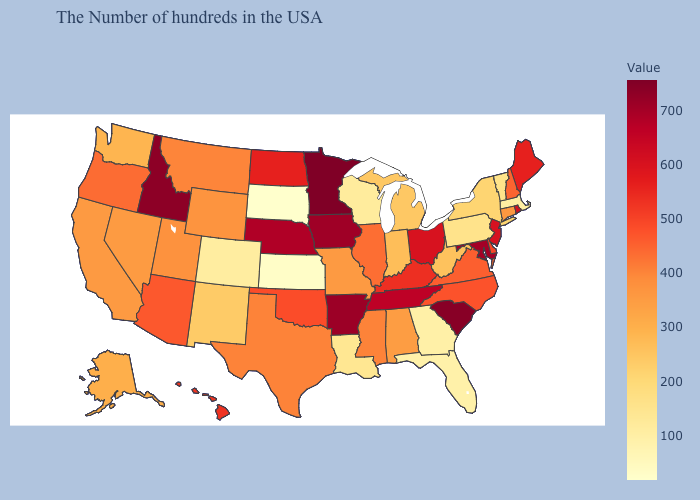Among the states that border Nebraska , does Iowa have the lowest value?
Short answer required. No. Is the legend a continuous bar?
Concise answer only. Yes. Is the legend a continuous bar?
Be succinct. Yes. Does Connecticut have the highest value in the USA?
Quick response, please. No. Among the states that border South Dakota , does Nebraska have the lowest value?
Concise answer only. No. Is the legend a continuous bar?
Concise answer only. Yes. Which states have the highest value in the USA?
Answer briefly. Minnesota. Which states hav the highest value in the South?
Write a very short answer. South Carolina. Among the states that border Oregon , does Idaho have the lowest value?
Give a very brief answer. No. 